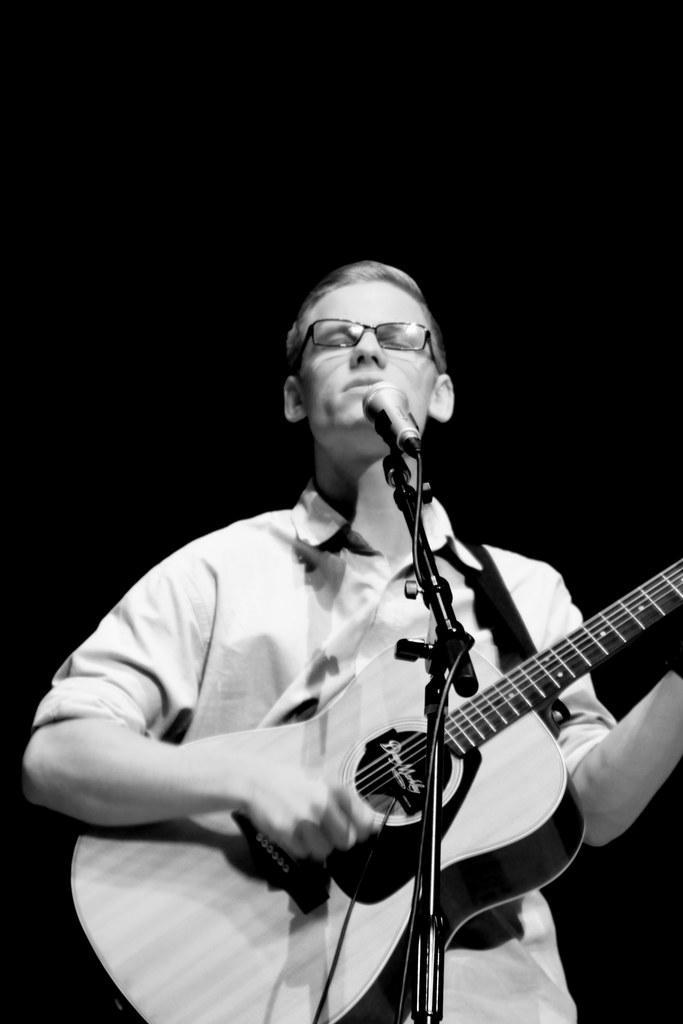Describe this image in one or two sentences. This is the picture where we can see a person with the spectacles. He is standing in front of mike and playing guitar. 